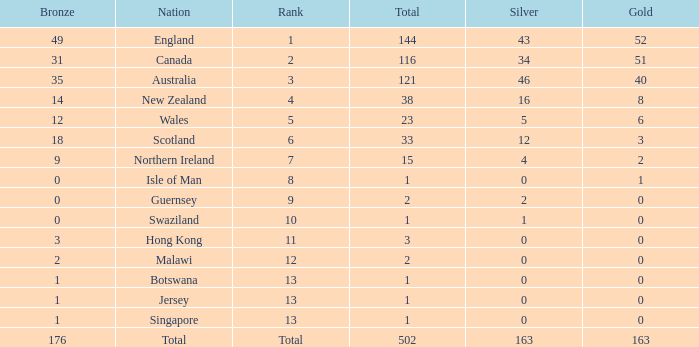Name the average bronze for total less than 1 None. 